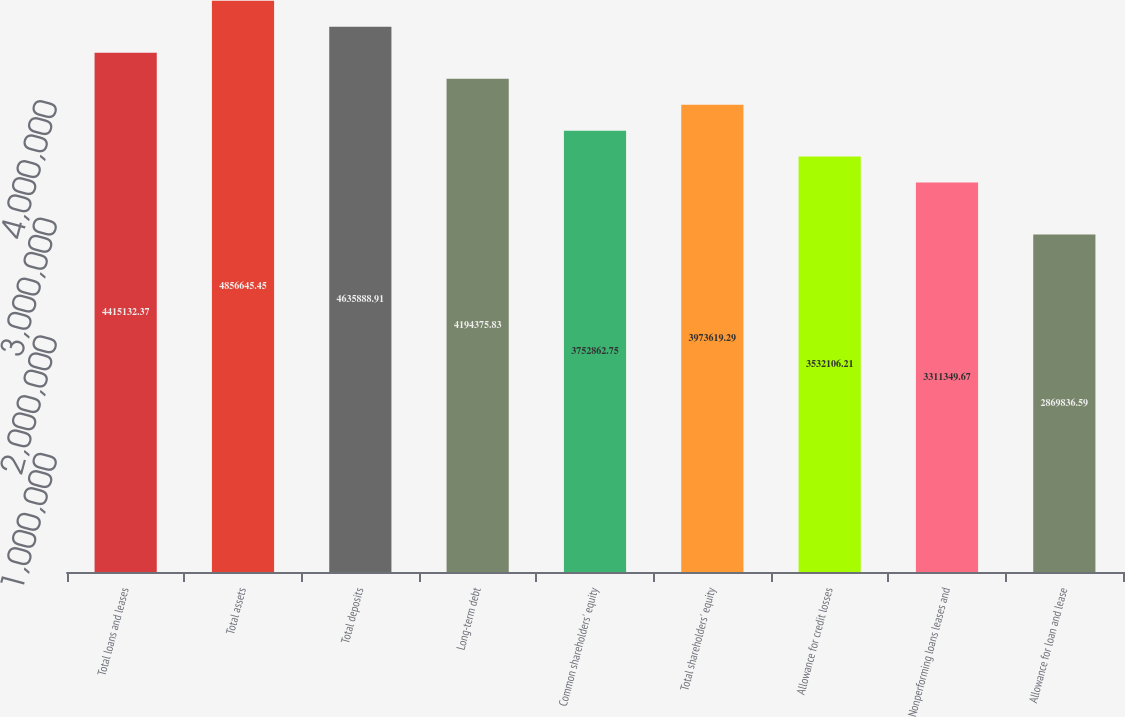Convert chart. <chart><loc_0><loc_0><loc_500><loc_500><bar_chart><fcel>Total loans and leases<fcel>Total assets<fcel>Total deposits<fcel>Long-term debt<fcel>Common shareholders' equity<fcel>Total shareholders' equity<fcel>Allowance for credit losses<fcel>Nonperforming loans leases and<fcel>Allowance for loan and lease<nl><fcel>4.41513e+06<fcel>4.85665e+06<fcel>4.63589e+06<fcel>4.19438e+06<fcel>3.75286e+06<fcel>3.97362e+06<fcel>3.53211e+06<fcel>3.31135e+06<fcel>2.86984e+06<nl></chart> 